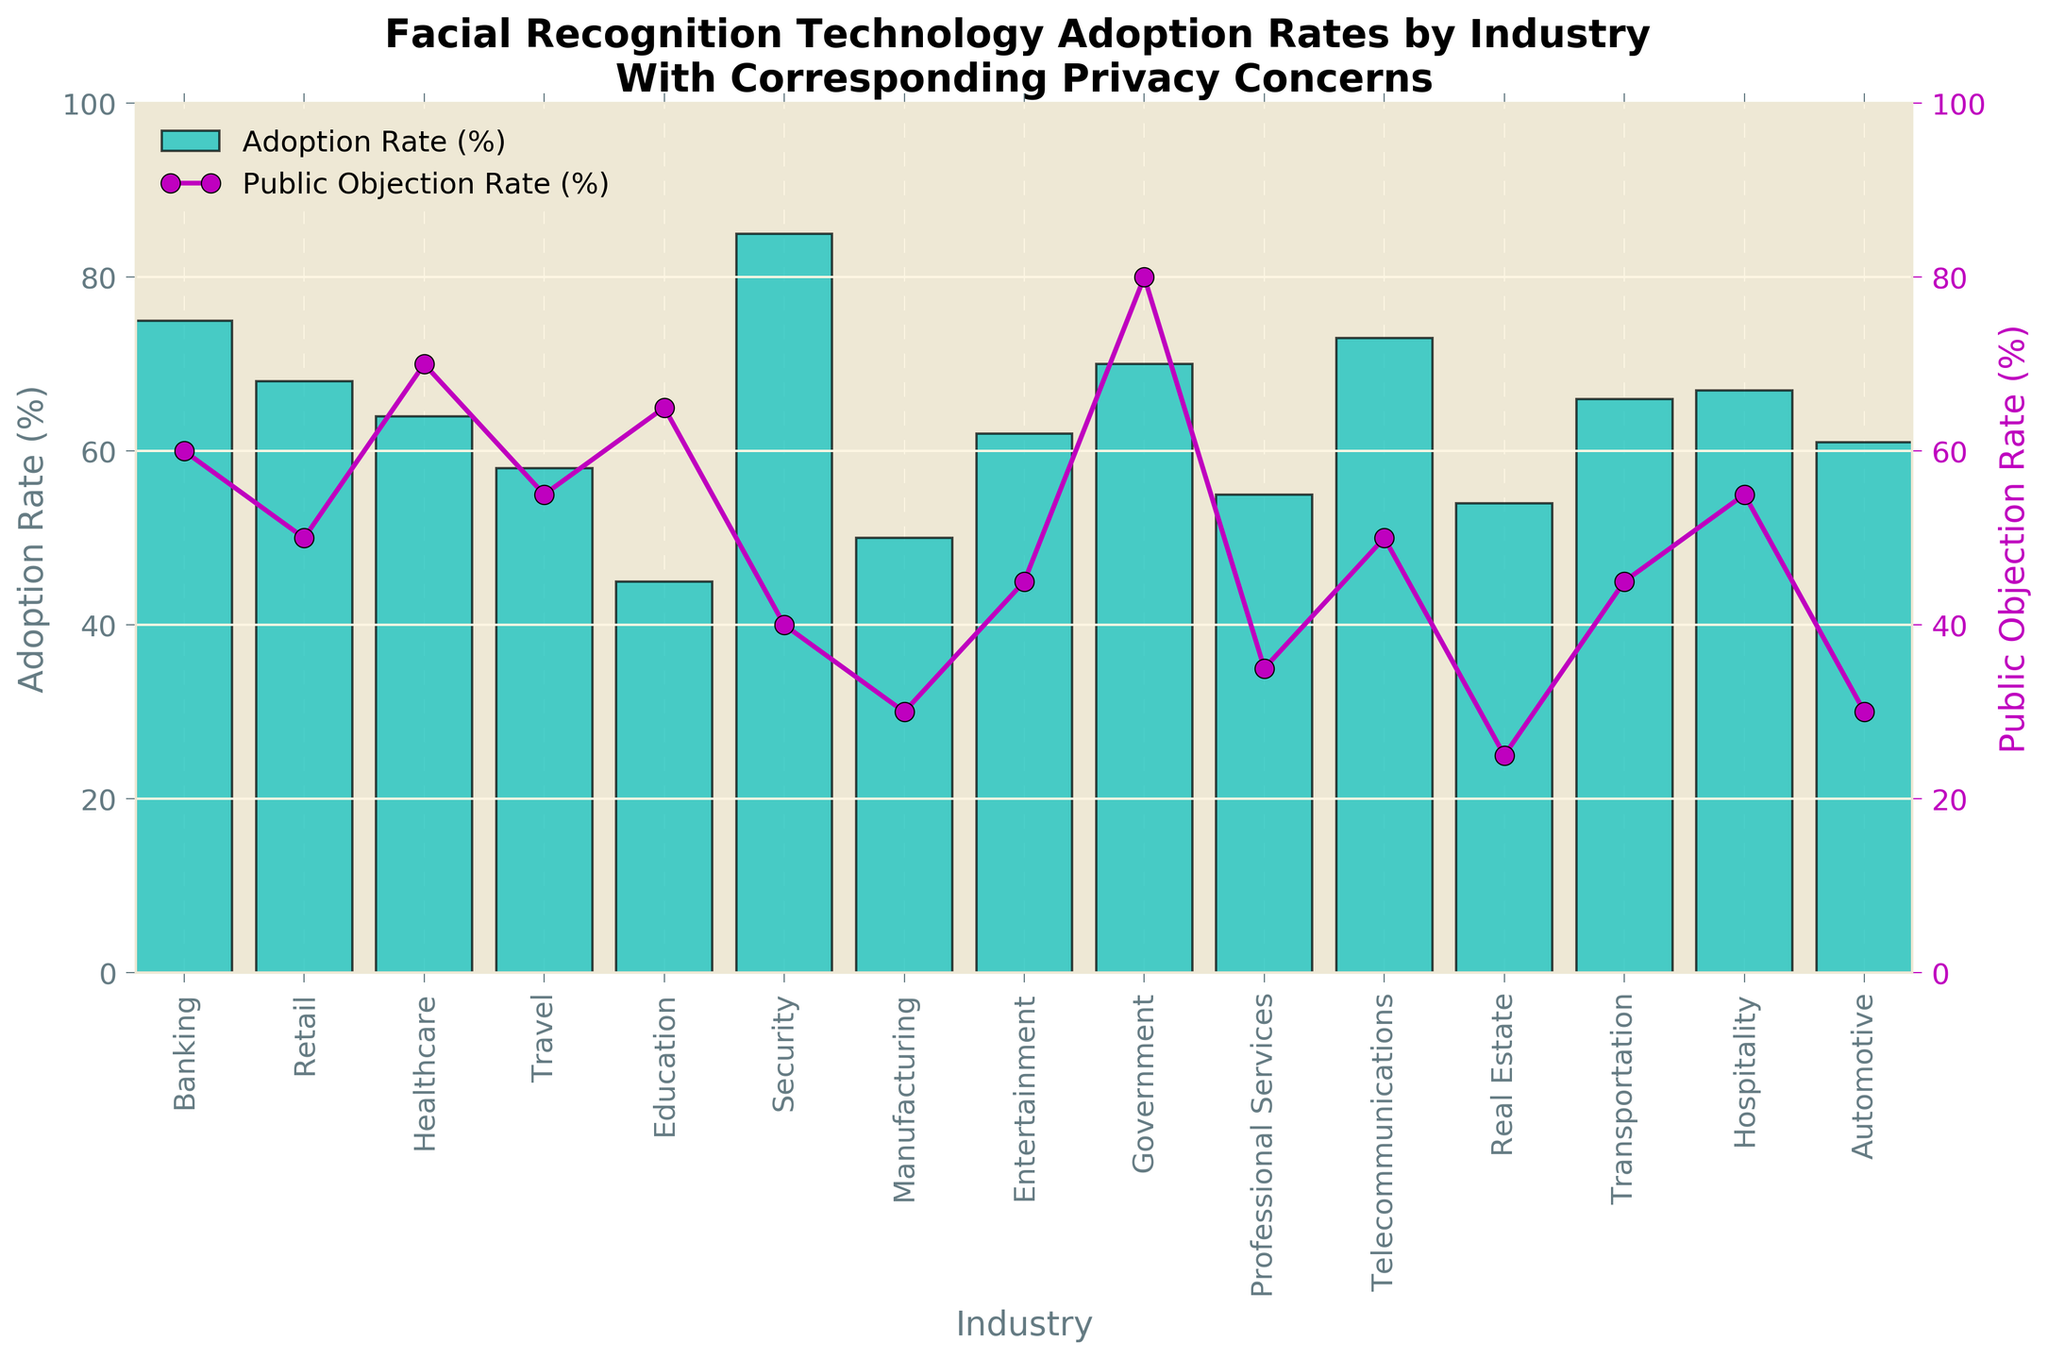Which industry has the highest adoption rate of facial recognition technology? The bar representing the 'Security' industry is the tallest among all the bars, indicating it has the highest adoption rate.
Answer: Security Which industry has both a high adoption rate and a high public objection rate? The 'Government' industry has a high adoption rate (indicated by a tall bar) and a high public objection rate (indicated by a high point on the purple line graph).
Answer: Government What is the difference between the adoption rate in the Banking industry and the Public Objection Rate in the same industry? The adoption rate for Banking is 75%, while the public objection rate is 60%. The difference is 75% - 60% = 15%.
Answer: 15% Which industry has the largest gap between its adoption rate and public objection rate? The largest gap can be calculated for each industry by subtracting the public objection rate from the adoption rate. The 'Security' industry has an 85% adoption rate and a 40% public objection rate, resulting in a 45% difference, which is the largest.
Answer: Security How does the public objection rate in the Healthcare industry compare to that in the Education industry? The purple line graph markers show that the public objection rate for Healthcare is 70%, while for Education, it is 65%. Healthcare's public objection rate is higher.
Answer: Healthcare Which industry has the lowest public objection rate and what is its adoption rate? The 'Real Estate' industry has the lowest public objection rate at 25%, as indicated by the lowest point on the purple line graph. Its adoption rate is 54%, as indicated by the height of the bar.
Answer: Real Estate, 54% On average, what is the public objection rate across all industries? To find the average public objection rate, add all the public objection rates and divide by the number of industries. (60 + 50 + 70 + 55 + 65 + 40 + 30 + 45 + 80 + 35 + 50 + 25 + 45 + 55 + 30) / 15 = 50%.
Answer: 50% In which industries do the adoption rate and public objection rate most closely match? By examining the graph, 'Travel' and 'Hospitality' industries have adoption rates and public objection rates that are close. 'Travel' has 58% adoption and 55% public objection; 'Hospitality' has 67% adoption and 55% public objection.
Answer: Travel and Hospitality 